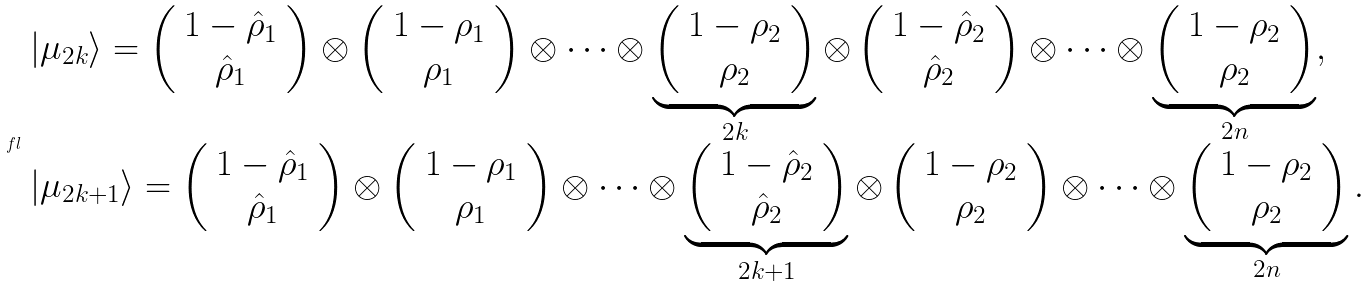Convert formula to latex. <formula><loc_0><loc_0><loc_500><loc_500>\ f l \begin{array} { l } | \mu _ { 2 k } \rangle = \left ( \begin{array} { c } 1 - \hat { \rho } _ { 1 } \\ \hat { \rho } _ { 1 } \end{array} \right ) \otimes \left ( \begin{array} { c } 1 - \rho _ { 1 } \\ \rho _ { 1 } \end{array} \right ) \otimes \cdots \otimes \underbrace { \left ( \begin{array} { c } 1 - \rho _ { 2 } \\ \rho _ { 2 } \end{array} \right ) } _ { 2 k } \otimes \left ( \begin{array} { c } 1 - \hat { \rho } _ { 2 } \\ \hat { \rho } _ { 2 } \end{array} \right ) \otimes \cdots \otimes \underbrace { \left ( \begin{array} { c } 1 - \rho _ { 2 } \\ \rho _ { 2 } \end{array} \right ) } _ { 2 n } , \\ | \mu _ { 2 k + 1 } \rangle = \left ( \begin{array} { c } 1 - \hat { \rho } _ { 1 } \\ \hat { \rho } _ { 1 } \end{array} \right ) \otimes \left ( \begin{array} { c } 1 - \rho _ { 1 } \\ \rho _ { 1 } \end{array} \right ) \otimes \cdots \otimes \underbrace { \left ( \begin{array} { c } 1 - \hat { \rho } _ { 2 } \\ \hat { \rho } _ { 2 } \end{array} \right ) } _ { 2 k + 1 } \otimes \left ( \begin{array} { c } 1 - \rho _ { 2 } \\ \rho _ { 2 } \end{array} \right ) \otimes \cdots \otimes \underbrace { \left ( \begin{array} { c } 1 - \rho _ { 2 } \\ \rho _ { 2 } \end{array} \right ) } _ { 2 n } . \end{array}</formula> 